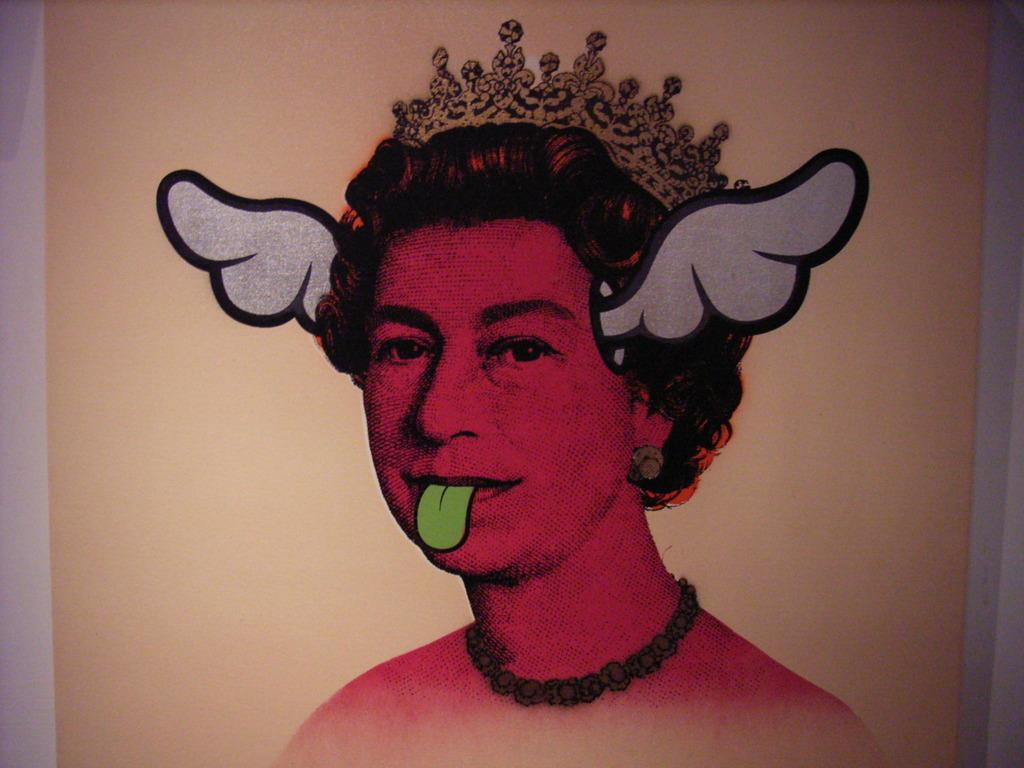What is the main subject of the image? There is a painting in the image. What does the painting depict? The painting depicts a person. Where is the painting located in the image? The painting is in the middle of the image. How many pigs are present in the painting? There are no pigs depicted in the painting; it features a person. What type of plate is used to serve the food in the painting? There is no plate or food present in the painting; it only depicts a person. 